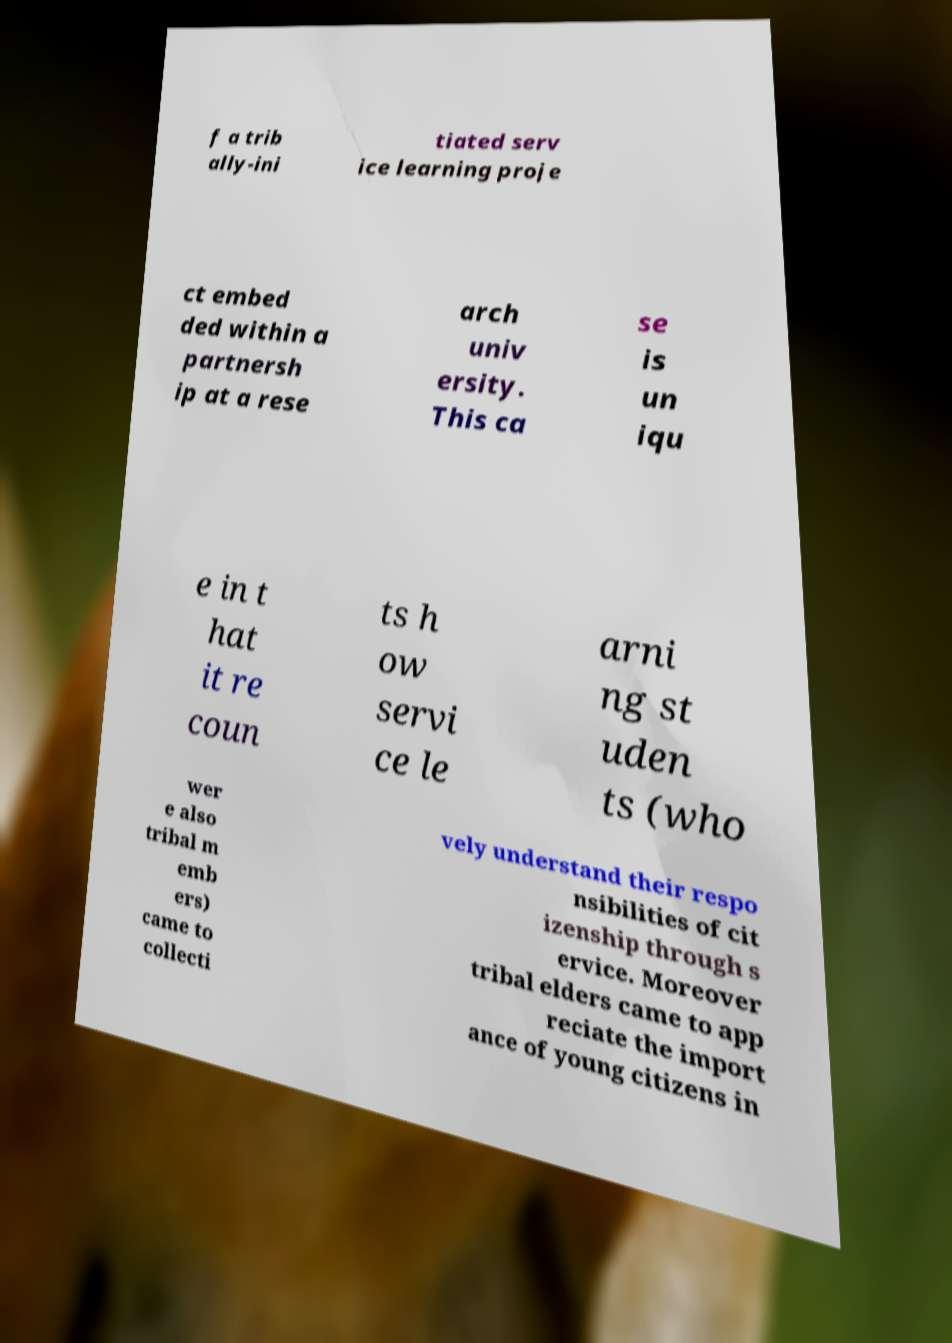I need the written content from this picture converted into text. Can you do that? f a trib ally-ini tiated serv ice learning proje ct embed ded within a partnersh ip at a rese arch univ ersity. This ca se is un iqu e in t hat it re coun ts h ow servi ce le arni ng st uden ts (who wer e also tribal m emb ers) came to collecti vely understand their respo nsibilities of cit izenship through s ervice. Moreover tribal elders came to app reciate the import ance of young citizens in 